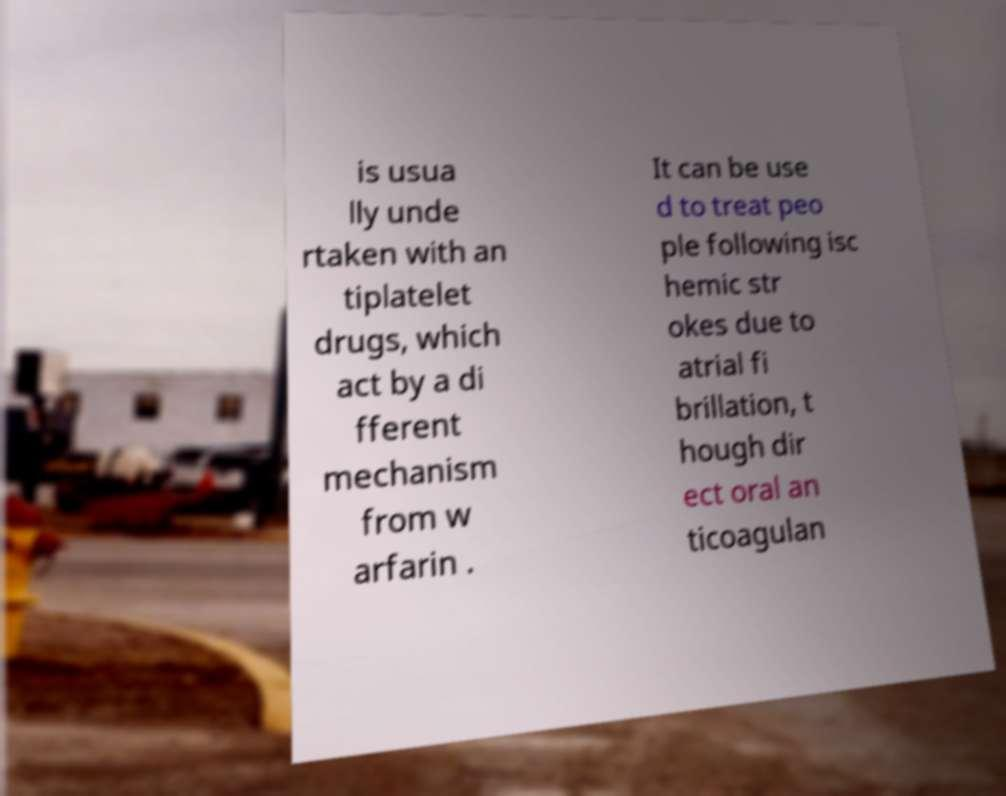Could you assist in decoding the text presented in this image and type it out clearly? is usua lly unde rtaken with an tiplatelet drugs, which act by a di fferent mechanism from w arfarin . It can be use d to treat peo ple following isc hemic str okes due to atrial fi brillation, t hough dir ect oral an ticoagulan 